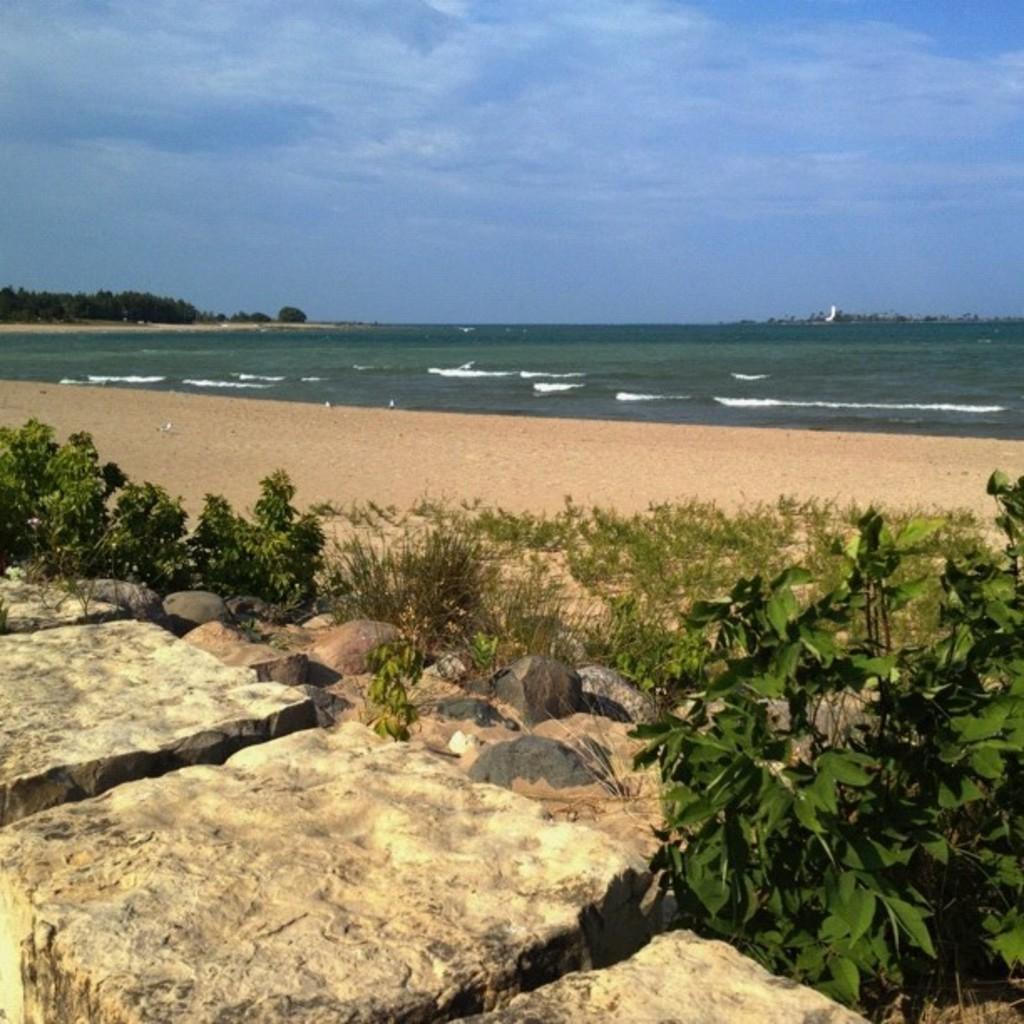Can you describe this image briefly? In this image we can see the ocean and there are some trees and plants and we can some stones at the bottom of the image. At the top we can see the sky with clouds. 